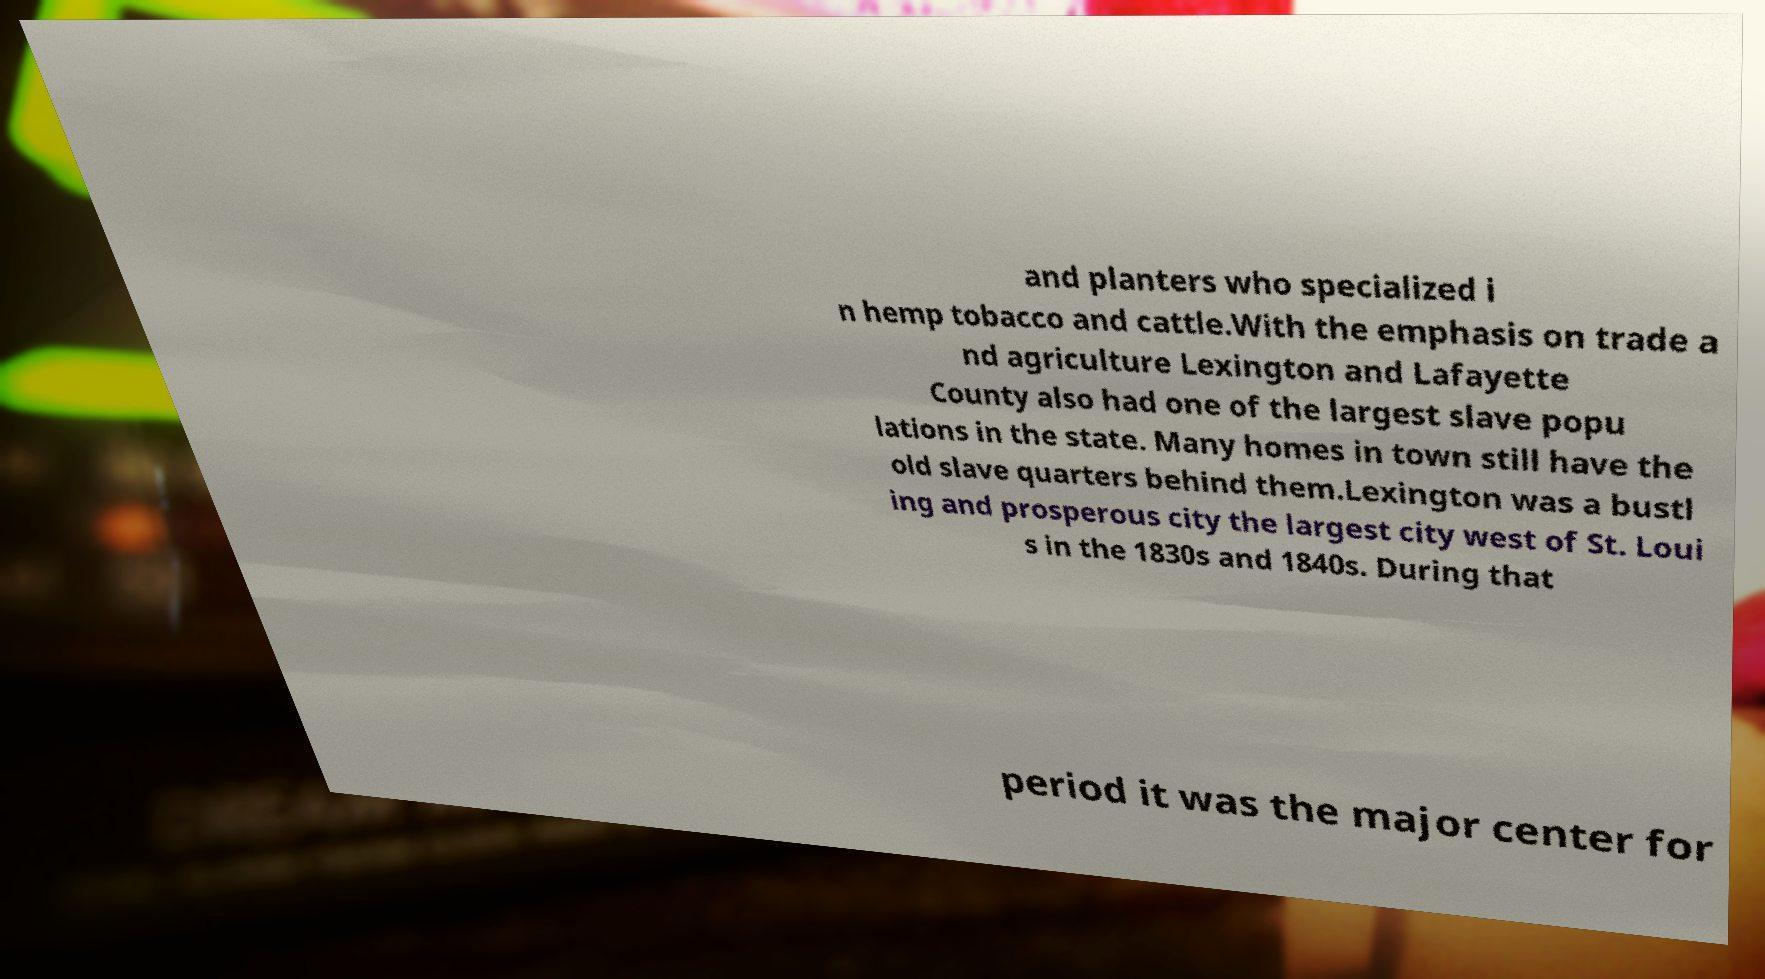Please read and relay the text visible in this image. What does it say? and planters who specialized i n hemp tobacco and cattle.With the emphasis on trade a nd agriculture Lexington and Lafayette County also had one of the largest slave popu lations in the state. Many homes in town still have the old slave quarters behind them.Lexington was a bustl ing and prosperous city the largest city west of St. Loui s in the 1830s and 1840s. During that period it was the major center for 